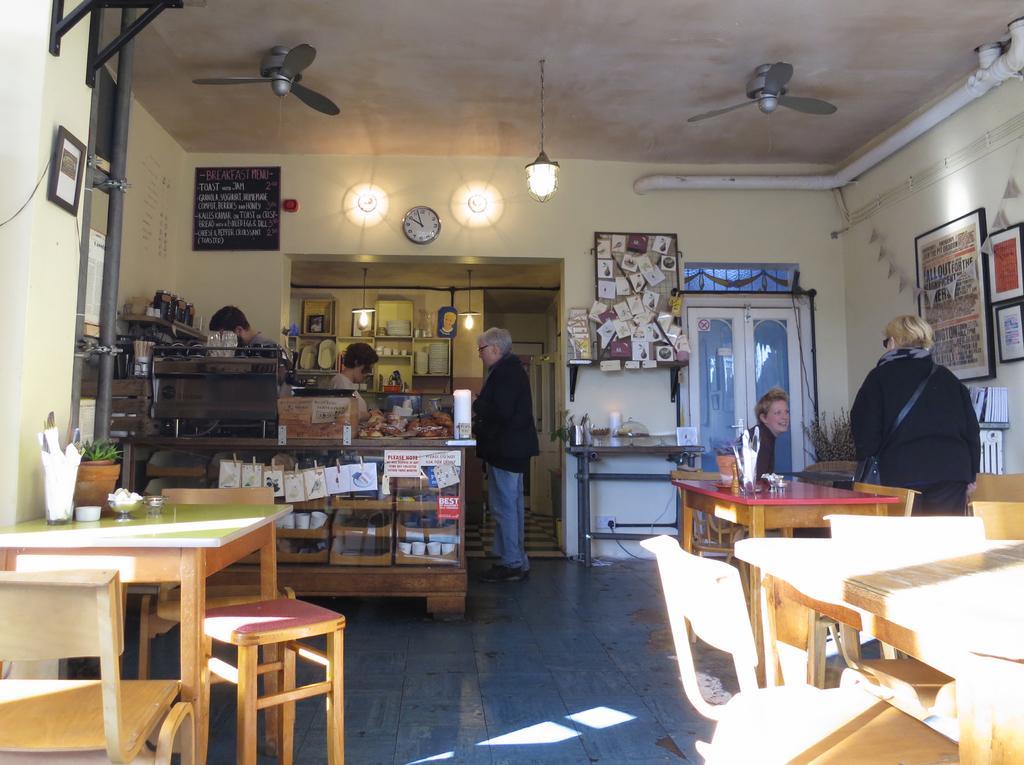How would you summarize this image in a sentence or two? The image is taken inside the room. On the left there is a table and on the right there is a lady standing next to her. There is another lady sitting. In the center there is a man standing near the counter. There are two people in the counter. In the background there is a door and a wall. There are clocks which are attached to the wall. At the top there is a chandelier and fans. 